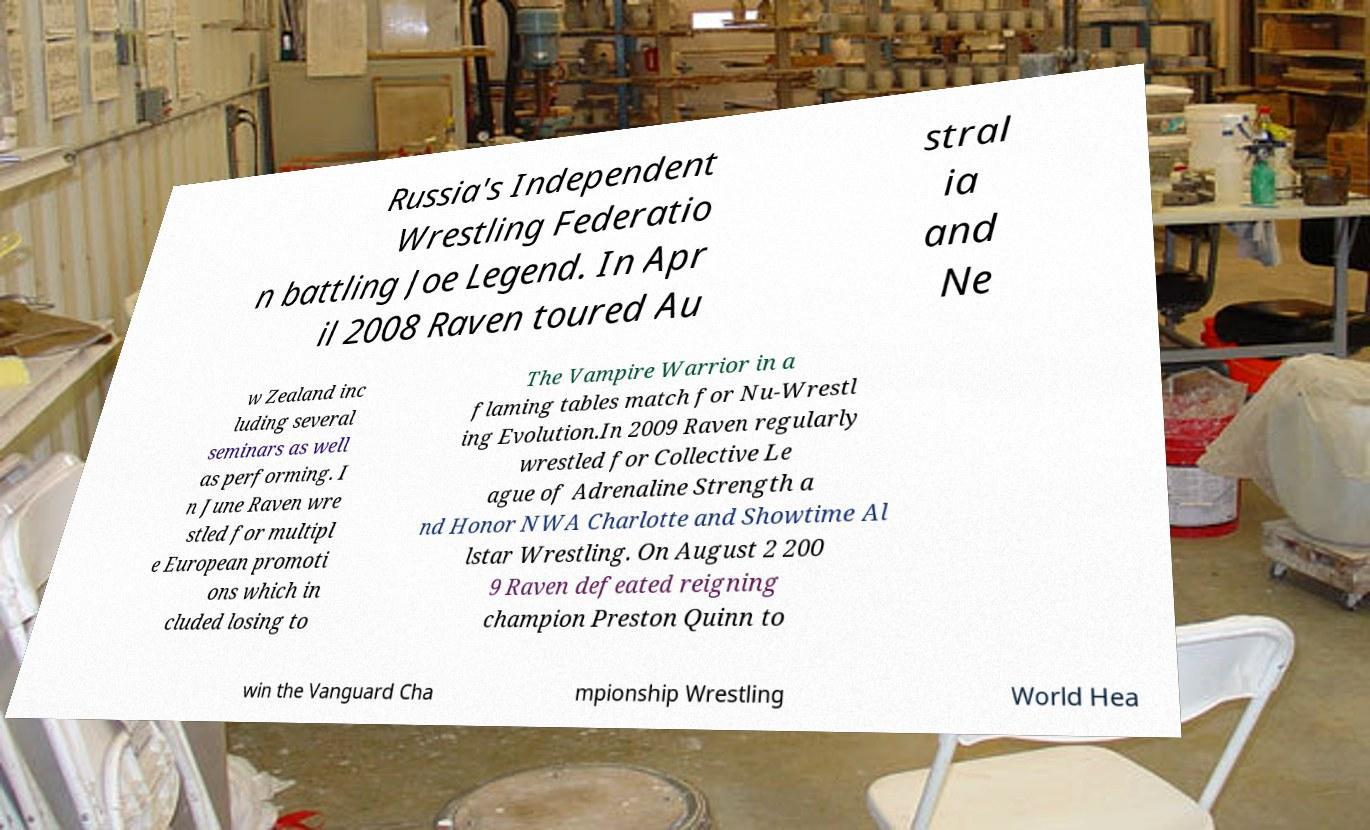Could you extract and type out the text from this image? Russia's Independent Wrestling Federatio n battling Joe Legend. In Apr il 2008 Raven toured Au stral ia and Ne w Zealand inc luding several seminars as well as performing. I n June Raven wre stled for multipl e European promoti ons which in cluded losing to The Vampire Warrior in a flaming tables match for Nu-Wrestl ing Evolution.In 2009 Raven regularly wrestled for Collective Le ague of Adrenaline Strength a nd Honor NWA Charlotte and Showtime Al lstar Wrestling. On August 2 200 9 Raven defeated reigning champion Preston Quinn to win the Vanguard Cha mpionship Wrestling World Hea 